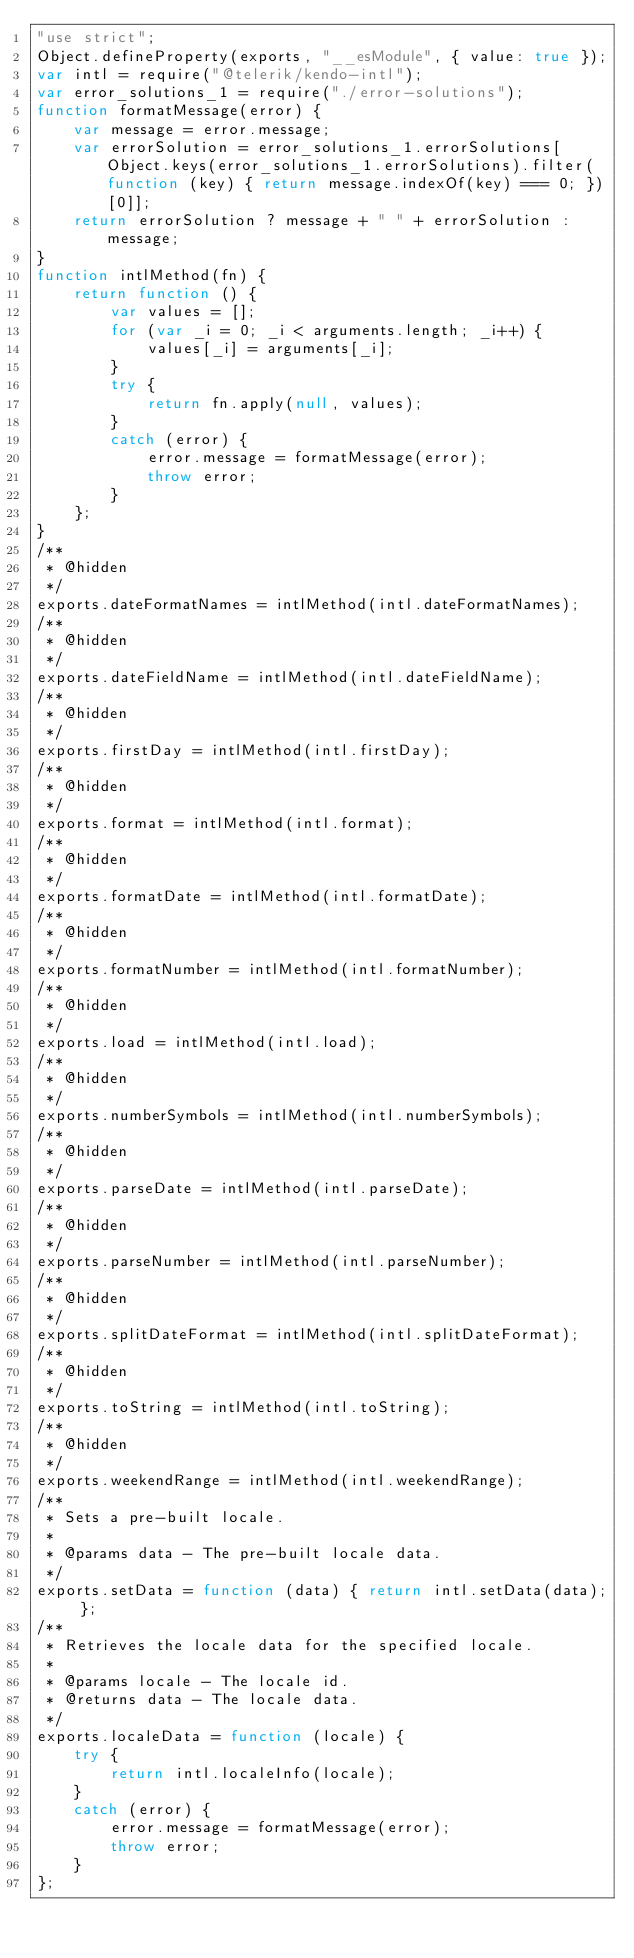<code> <loc_0><loc_0><loc_500><loc_500><_JavaScript_>"use strict";
Object.defineProperty(exports, "__esModule", { value: true });
var intl = require("@telerik/kendo-intl");
var error_solutions_1 = require("./error-solutions");
function formatMessage(error) {
    var message = error.message;
    var errorSolution = error_solutions_1.errorSolutions[Object.keys(error_solutions_1.errorSolutions).filter(function (key) { return message.indexOf(key) === 0; })[0]];
    return errorSolution ? message + " " + errorSolution : message;
}
function intlMethod(fn) {
    return function () {
        var values = [];
        for (var _i = 0; _i < arguments.length; _i++) {
            values[_i] = arguments[_i];
        }
        try {
            return fn.apply(null, values);
        }
        catch (error) {
            error.message = formatMessage(error);
            throw error;
        }
    };
}
/**
 * @hidden
 */
exports.dateFormatNames = intlMethod(intl.dateFormatNames);
/**
 * @hidden
 */
exports.dateFieldName = intlMethod(intl.dateFieldName);
/**
 * @hidden
 */
exports.firstDay = intlMethod(intl.firstDay);
/**
 * @hidden
 */
exports.format = intlMethod(intl.format);
/**
 * @hidden
 */
exports.formatDate = intlMethod(intl.formatDate);
/**
 * @hidden
 */
exports.formatNumber = intlMethod(intl.formatNumber);
/**
 * @hidden
 */
exports.load = intlMethod(intl.load);
/**
 * @hidden
 */
exports.numberSymbols = intlMethod(intl.numberSymbols);
/**
 * @hidden
 */
exports.parseDate = intlMethod(intl.parseDate);
/**
 * @hidden
 */
exports.parseNumber = intlMethod(intl.parseNumber);
/**
 * @hidden
 */
exports.splitDateFormat = intlMethod(intl.splitDateFormat);
/**
 * @hidden
 */
exports.toString = intlMethod(intl.toString);
/**
 * @hidden
 */
exports.weekendRange = intlMethod(intl.weekendRange);
/**
 * Sets a pre-built locale.
 *
 * @params data - The pre-built locale data.
 */
exports.setData = function (data) { return intl.setData(data); };
/**
 * Retrieves the locale data for the specified locale.
 *
 * @params locale - The locale id.
 * @returns data - The locale data.
 */
exports.localeData = function (locale) {
    try {
        return intl.localeInfo(locale);
    }
    catch (error) {
        error.message = formatMessage(error);
        throw error;
    }
};
</code> 